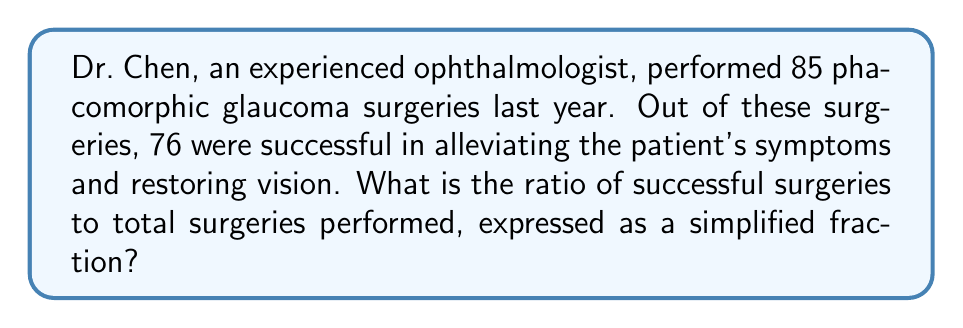Help me with this question. To find the ratio of successful surgeries to total surgeries, we need to follow these steps:

1. Identify the number of successful surgeries: 76
2. Identify the total number of surgeries: 85
3. Write the ratio as a fraction: $\frac{76}{85}$
4. Simplify the fraction:

To simplify, we need to find the greatest common divisor (GCD) of 76 and 85.

Using the Euclidean algorithm:
$$85 = 1 \times 76 + 9$$
$$76 = 8 \times 9 + 4$$
$$9 = 2 \times 4 + 1$$
$$4 = 4 \times 1 + 0$$

The GCD is 1, which means the fraction $\frac{76}{85}$ is already in its simplest form.

Therefore, the ratio of successful surgeries to total surgeries is $\frac{76}{85}$.
Answer: $\frac{76}{85}$ 